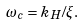Convert formula to latex. <formula><loc_0><loc_0><loc_500><loc_500>\omega _ { c } = k _ { H } / \xi .</formula> 